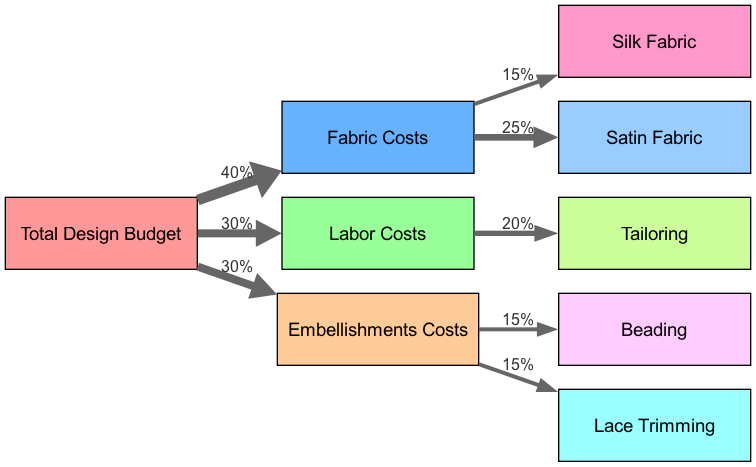What is the total design budget for the bridesmaids' dresses? The total design budget is the top node in the diagram, which connects to the other cost categories. The values attached to the links specify how the budget is divided among these categories. Given that all of them sum to the total budget, we have to add those values: 40 (Fabric Costs) + 30 (Labor Costs) + 30 (Embellishments Costs) = 100.
Answer: 100 How much is allocated to fabric costs? The fabric costs can be found by checking the link from the Total Design Budget to Fabric Costs. It indicates a value of 40, representing the percentage of the total budget allocated specifically to fabric.
Answer: 40 What percentage of the budget is spent on tailoring? Tailoring is a subcategory under Labor Costs. Moving from Total Design Budget to Labor Costs, and then down to Tailoring, we note the link has a value of 20, which indicates that 20 percent of the total budget is allocated to tailoring.
Answer: 20 Which fabric has the highest allocation? On examining the links from Fabric Costs to its subcategories (Silk Fabric and Satin Fabric), the values are 15 for Silk Fabric and 25 for Satin Fabric. Since 25 > 15, Satin Fabric has the highest allocation.
Answer: Satin Fabric What is the total percentage spent on embellishments? Embellishments Costs is a direct category under the Total Design Budget. The link from Total Design Budget to Embellishments Costs has a value of 30, meaning 30 percent of the total budget is allocated for embellishments.
Answer: 30 How many total nodes are in the diagram? The total nodes include categories and subcategories involved in the budget. Counting them yields nine distinct nodes: Total Design Budget, Fabric Costs, Labor Costs, Embellishments Costs, Silk Fabric, Satin Fabric, Tailoring, Beading, and Lace Trimming.
Answer: 9 What percentage is allocated to beading and lace trimming combined? Beading and Lace Trimming are subcategories under Embellishments Costs, with each having a value of 15. Thus, we sum these two values: 15 (Beading) + 15 (Lace Trimming) = 30, indicating that 30 percent of the budget is allocated to both embellishments combined.
Answer: 30 Which allocation is greater: Labor Costs or Embellishments Costs? To answer this, we look at the values linked from Total Design Budget; Labor Costs is at 30 and Embellishments Costs is also at 30. Since both values are equal, we conclude they are the same.
Answer: Equal 